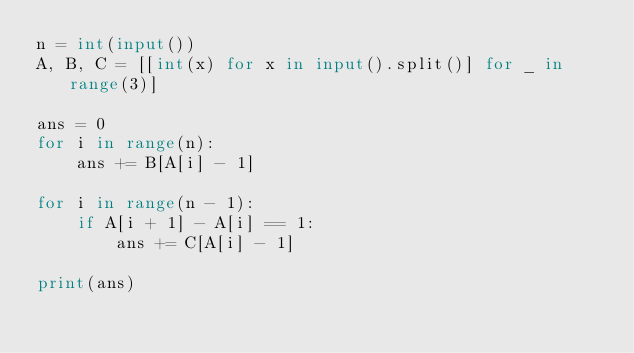Convert code to text. <code><loc_0><loc_0><loc_500><loc_500><_Python_>n = int(input())
A, B, C = [[int(x) for x in input().split()] for _ in range(3)]

ans = 0
for i in range(n):
    ans += B[A[i] - 1]

for i in range(n - 1):
    if A[i + 1] - A[i] == 1:
        ans += C[A[i] - 1]

print(ans)
</code> 